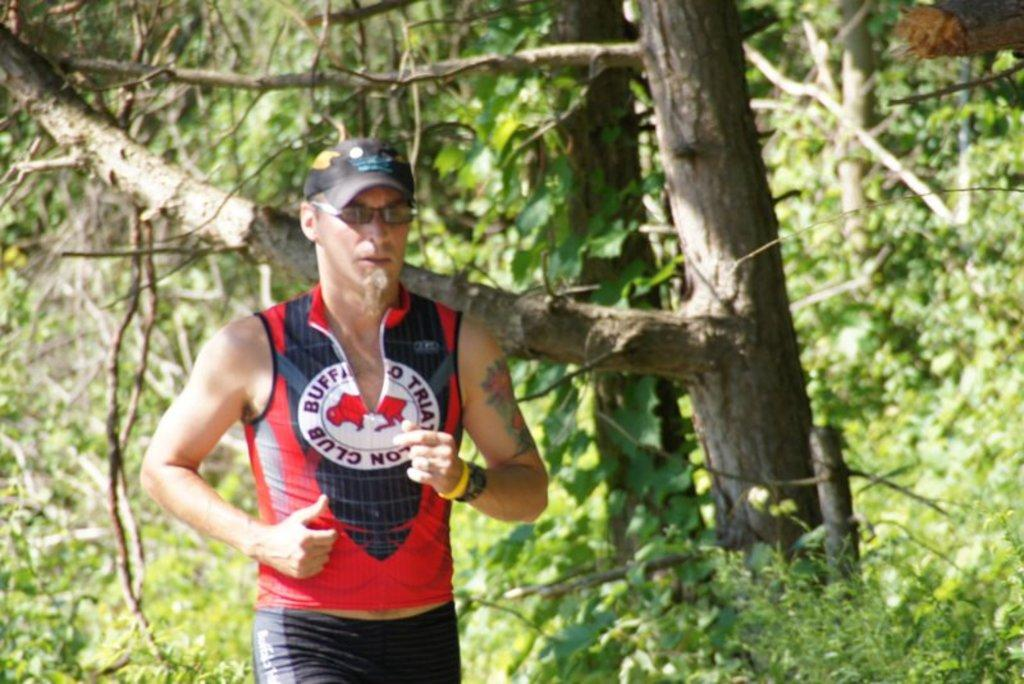<image>
Give a short and clear explanation of the subsequent image. A running man is wearing a Buffalo Triathlon Club shirt. 